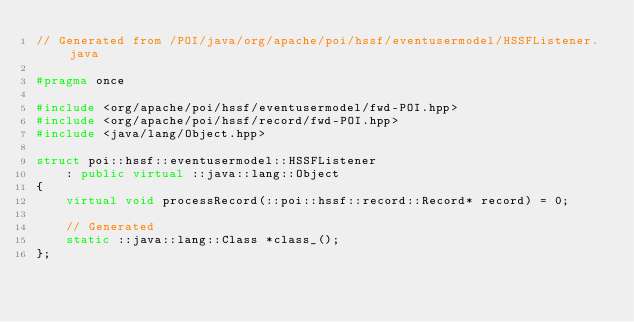<code> <loc_0><loc_0><loc_500><loc_500><_C++_>// Generated from /POI/java/org/apache/poi/hssf/eventusermodel/HSSFListener.java

#pragma once

#include <org/apache/poi/hssf/eventusermodel/fwd-POI.hpp>
#include <org/apache/poi/hssf/record/fwd-POI.hpp>
#include <java/lang/Object.hpp>

struct poi::hssf::eventusermodel::HSSFListener
    : public virtual ::java::lang::Object
{
    virtual void processRecord(::poi::hssf::record::Record* record) = 0;

    // Generated
    static ::java::lang::Class *class_();
};
</code> 